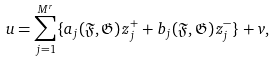Convert formula to latex. <formula><loc_0><loc_0><loc_500><loc_500>u = \sum _ { j = 1 } ^ { M ^ { r } } \{ a _ { j } ( \mathfrak F , \mathfrak G ) \, z _ { j } ^ { + } + b _ { j } ( \mathfrak F , \mathfrak G ) \, z _ { j } ^ { - } \} + v ,</formula> 